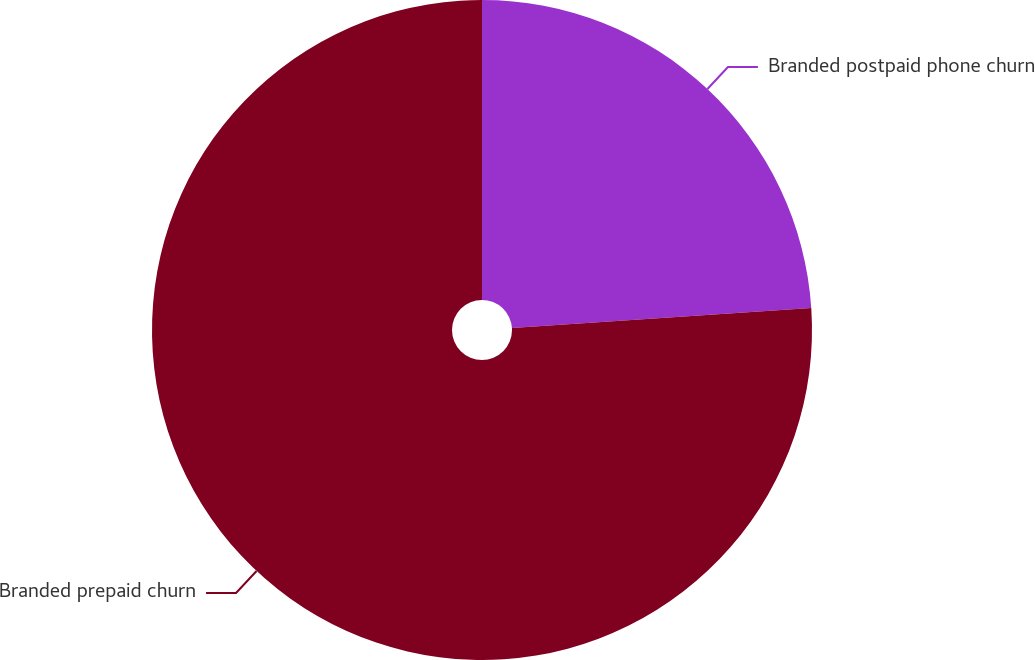<chart> <loc_0><loc_0><loc_500><loc_500><pie_chart><fcel>Branded postpaid phone churn<fcel>Branded prepaid churn<nl><fcel>23.94%<fcel>76.06%<nl></chart> 